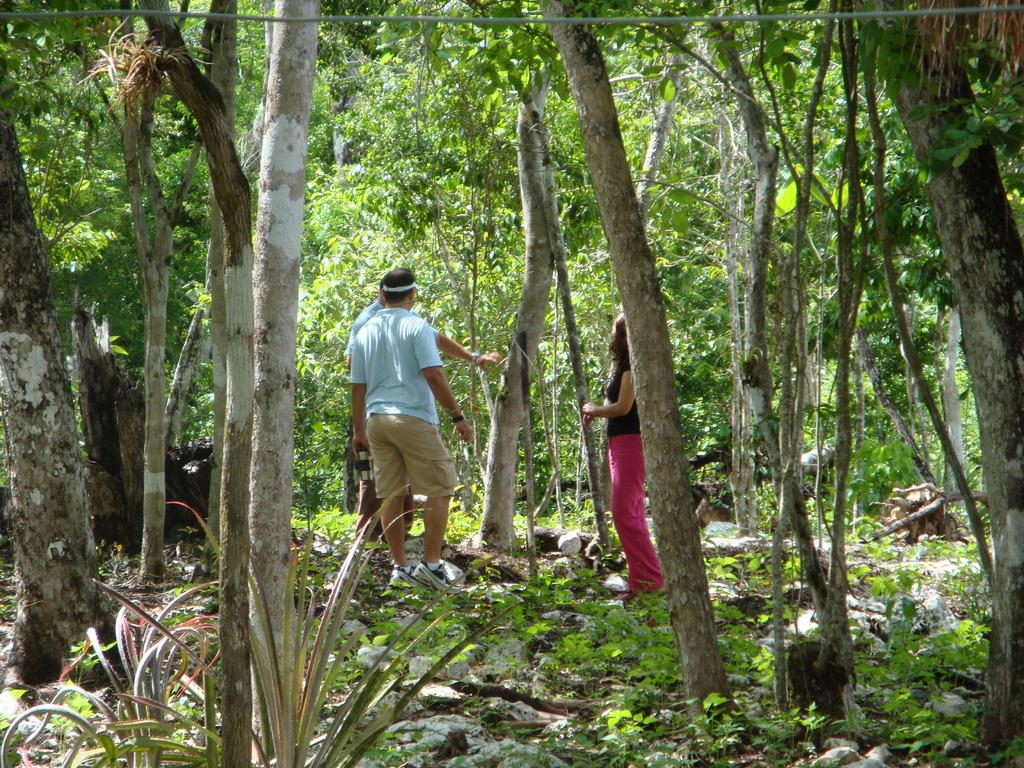What can be seen in the image? There are people standing in the image. What is visible in the background of the image? There are trees and plants in the background of the image. How many giraffes can be seen in the image? There are no giraffes present in the image. What color are the eyes of the people in the image? The provided facts do not mention the color of the people's eyes, so we cannot determine that information from the image. 